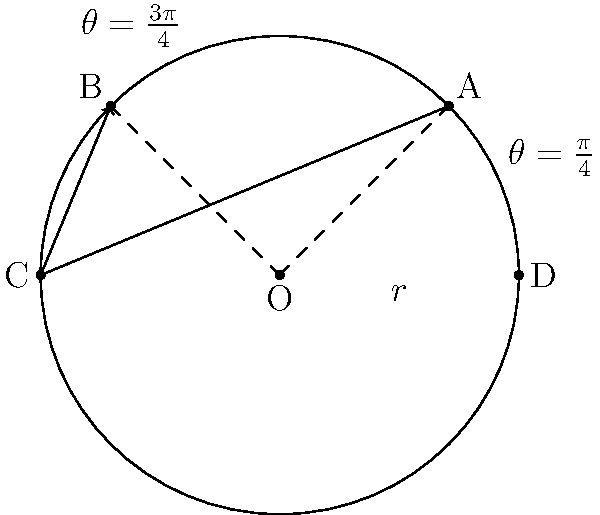In a chess-inspired polar coordinate system, a bishop moves along the path from point A to point C to point B, as shown in the diagram. If the circle has a radius $r$, what is the area of the region swept by the bishop's path in terms of $r$? Let's approach this step-by-step:

1) The bishop's path forms a triangle AOB, where O is the origin.

2) In polar coordinates, the area of a sector is given by $A = \frac{1}{2} r^2 \theta$, where $\theta$ is in radians.

3) The angle AOB is $\frac{\pi}{2}$ radians (90°), as it's the difference between $\frac{3\pi}{4}$ and $\frac{\pi}{4}$.

4) Therefore, the area of the sector AOB is:
   $A_{sector} = \frac{1}{2} r^2 \cdot \frac{\pi}{2} = \frac{\pi r^2}{4}$

5) Now, we need to subtract the area of triangle AOB from this sector.

6) The area of triangle AOB can be calculated using the formula:
   $A_{triangle} = \frac{1}{2} \cdot base \cdot height$

7) The base and height of this triangle are both $r\sqrt{2}$ (as they are the diagonals of a square with side $r$).

8) So, $A_{triangle} = \frac{1}{2} \cdot r\sqrt{2} \cdot r\sqrt{2} = r^2$

9) The area swept by the bishop's path is the difference between the sector and the triangle:

   $A_{swept} = A_{sector} - A_{triangle} = \frac{\pi r^2}{4} - r^2 = r^2(\frac{\pi}{4} - 1)$
Answer: $r^2(\frac{\pi}{4} - 1)$ 